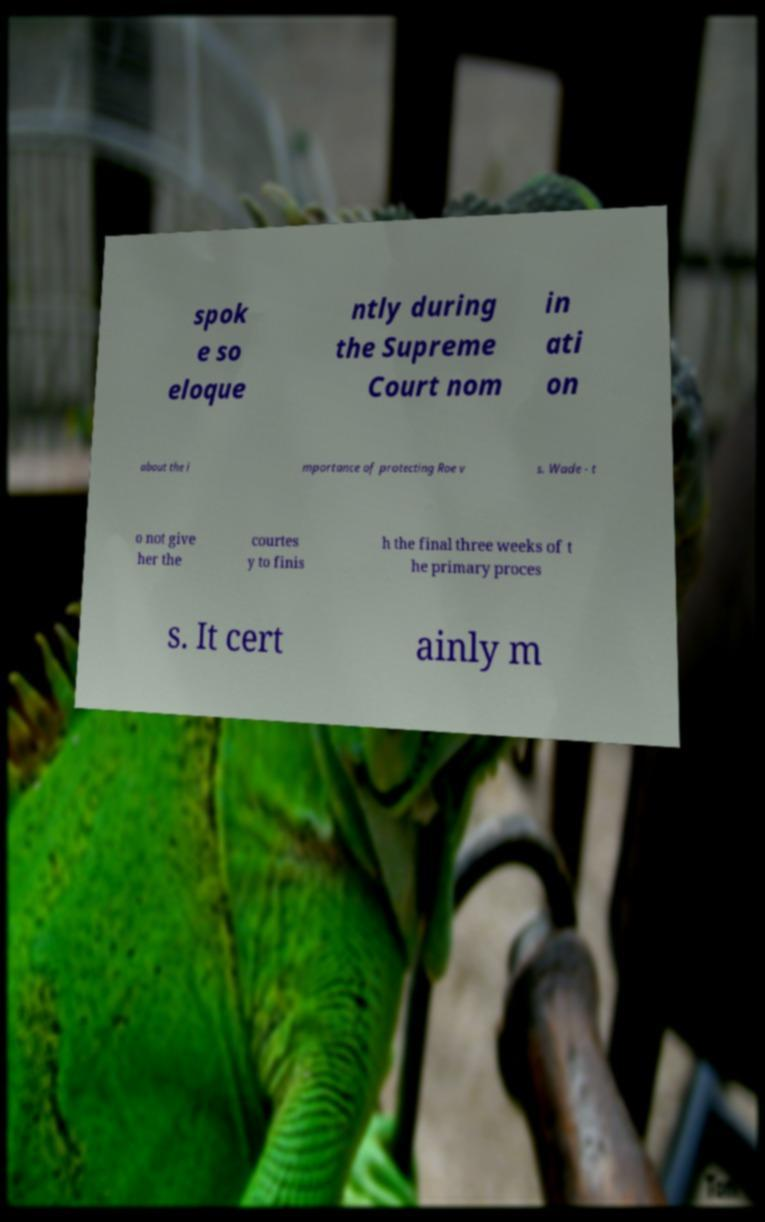Please read and relay the text visible in this image. What does it say? spok e so eloque ntly during the Supreme Court nom in ati on about the i mportance of protecting Roe v s. Wade - t o not give her the courtes y to finis h the final three weeks of t he primary proces s. It cert ainly m 